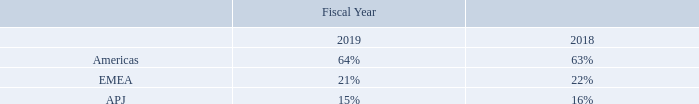Net revenues by geographical region
Percentage of revenue by geographic region as presented below is based on the billing location of the customer.
Percentages may not add to 100% due to rounding.
The Americas include U.S., Canada, and Latin America; EMEA includes Europe, Middle East, and Africa; APJ includes Asia Pacific and Japan.
What regions are included in the Americas? U.s., canada, and latin america. What does the table show? Net revenues by geographical region. How is geographical location of the customer determined? Based on the billing location of the customer. What is the change in percentage of revenue for Americas from fiscal 2018 to 2019?
Answer scale should be: percent. 64-63
Answer: 1. What is the change in percentage of revenue for EMEA from fiscal 2018 to 2019?
Answer scale should be: percent. 21-22
Answer: -1. What is the change in percentage of revenue for APJ from fiscal 2018 to 2019?
Answer scale should be: percent. 15-16
Answer: -1. 